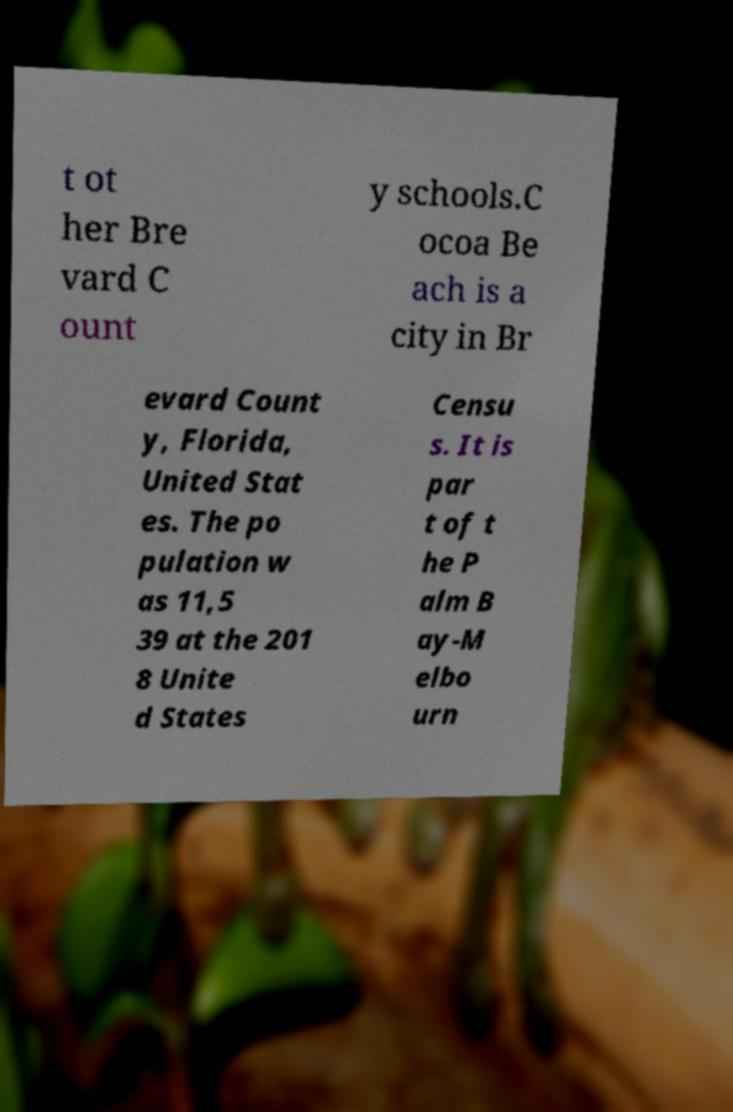Please identify and transcribe the text found in this image. t ot her Bre vard C ount y schools.C ocoa Be ach is a city in Br evard Count y, Florida, United Stat es. The po pulation w as 11,5 39 at the 201 8 Unite d States Censu s. It is par t of t he P alm B ay-M elbo urn 